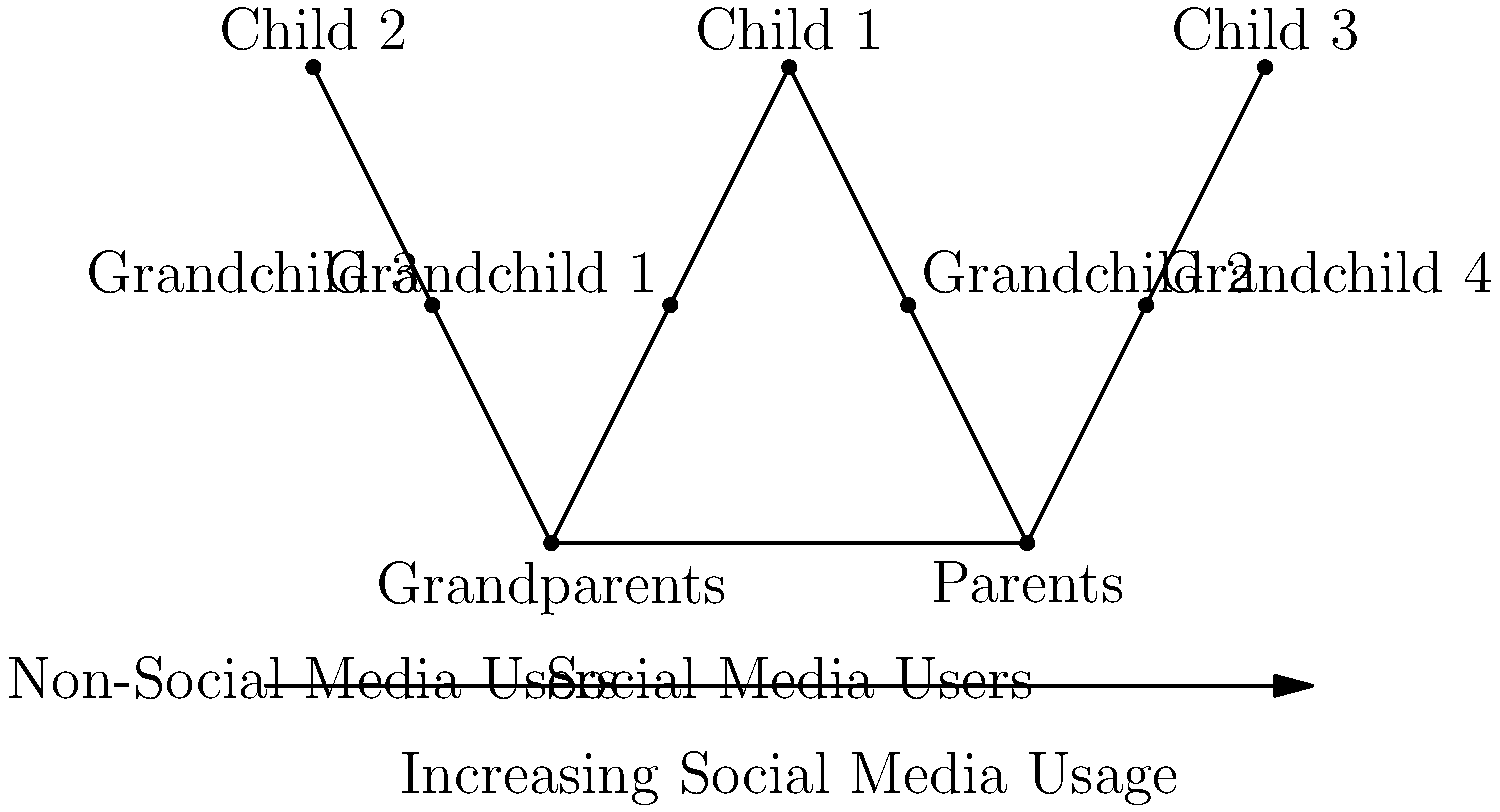Based on the family tree diagram, which illustrates varying levels of social media usage across generations, analyze how the adoption of social media platforms might affect intergenerational relationships and cultural transmission within this family structure. Consider the potential benefits and challenges in maintaining family bonds and sharing cultural knowledge across different levels of technological engagement. To analyze the impact of social media on intergenerational relationships and cultural transmission within this family structure, we need to consider several factors:

1. Digital divide: The diagram shows a clear division between social media users and non-users, with older generations (grandparents) being non-users and younger generations (children and grandchildren) being users.

2. Communication patterns:
   a) Between users: Social media can facilitate more frequent and instant communication among users (children and grandchildren).
   b) With non-users: There may be a communication gap between social media users and non-users (grandparents), potentially leading to reduced interaction.

3. Cultural transmission:
   a) Traditional methods: Grandparents may rely on face-to-face interactions or non-digital means to share cultural knowledge.
   b) Digital methods: Younger generations might use social media to document and share cultural experiences, potentially reaching a wider audience but excluding non-users.

4. Family bonds:
   a) Strengthening: Social media can help maintain connections between geographically distant family members.
   b) Weakening: Over-reliance on digital communication might reduce the quality of in-person interactions.

5. Generational perspectives:
   a) Older generations may feel excluded from certain family interactions or struggle to understand modern cultural references.
   b) Younger generations might miss out on traditional cultural knowledge if not actively shared through non-digital means.

6. Adaptation and learning:
   a) Opportunity for older generations to learn new technologies from younger family members.
   b) Younger generations can learn to value and seek out traditional forms of cultural transmission.

7. Cultural change:
   a) Social media can accelerate cultural changes and introduce new elements to family traditions.
   b) It may also serve as a platform for preserving and revitalizing cultural practices.

The impact of social media on intergenerational relationships and cultural transmission in this family structure is likely to be mixed, with both positive and negative effects. The key to maintaining strong family bonds and effective cultural transmission lies in finding a balance between digital and traditional forms of communication and actively working to bridge the digital divide.
Answer: Mixed impact: enhanced connectivity but potential communication gaps; requires balance between digital and traditional cultural transmission methods. 